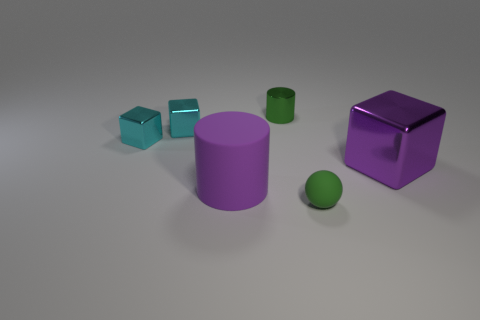The metallic cylinder that is the same color as the tiny rubber ball is what size?
Give a very brief answer. Small. What material is the tiny green ball?
Provide a short and direct response. Rubber. What is the shape of the small object that is the same color as the small ball?
Give a very brief answer. Cylinder. How many rubber things are the same size as the green cylinder?
Keep it short and to the point. 1. What number of objects are either green things left of the tiny green rubber ball or big purple objects that are to the right of the green shiny cylinder?
Give a very brief answer. 2. Do the big object that is on the right side of the green rubber ball and the purple thing that is on the left side of the sphere have the same material?
Keep it short and to the point. No. There is a small metal thing to the right of the large object that is to the left of the green cylinder; what shape is it?
Give a very brief answer. Cylinder. Are there any other things that are the same color as the large metallic block?
Make the answer very short. Yes. There is a matte thing left of the green thing that is behind the big rubber cylinder; is there a big purple shiny thing to the left of it?
Your answer should be very brief. No. There is a big metal cube that is on the right side of the tiny green shiny object; is it the same color as the small thing in front of the large purple cylinder?
Give a very brief answer. No. 